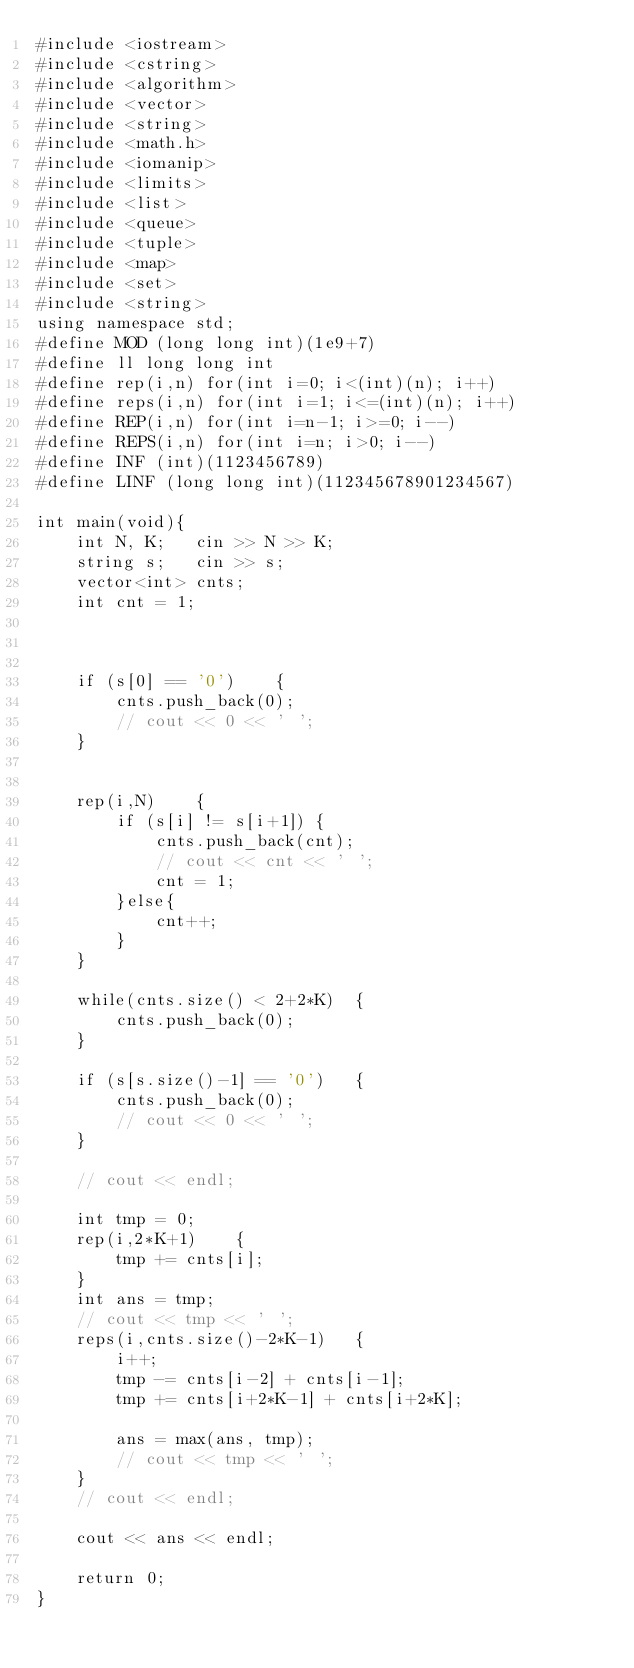<code> <loc_0><loc_0><loc_500><loc_500><_C++_>#include <iostream>
#include <cstring>
#include <algorithm>
#include <vector>
#include <string>
#include <math.h>
#include <iomanip>
#include <limits>
#include <list>
#include <queue>
#include <tuple>
#include <map>
#include <set>
#include <string>
using namespace std;
#define MOD (long long int)(1e9+7)
#define ll long long int
#define rep(i,n) for(int i=0; i<(int)(n); i++)
#define reps(i,n) for(int i=1; i<=(int)(n); i++)
#define REP(i,n) for(int i=n-1; i>=0; i--)
#define REPS(i,n) for(int i=n; i>0; i--)
#define INF (int)(1123456789)
#define LINF (long long int)(112345678901234567)

int main(void){
	int N, K;	cin >> N >> K;
	string s;	cin >> s;
	vector<int> cnts;
	int cnt = 1;



	if (s[0] == '0')	{
		cnts.push_back(0);
		// cout << 0 << ' ';
	}


	rep(i,N)	{
		if (s[i] != s[i+1])	{
			cnts.push_back(cnt);
			// cout << cnt << ' ';
			cnt = 1;
		}else{
			cnt++;
		}
	}

	while(cnts.size() < 2+2*K)	{
		cnts.push_back(0);
	}

	if (s[s.size()-1] == '0')	{
		cnts.push_back(0);
		// cout << 0 << ' ';
	}

	// cout << endl;

	int tmp = 0;
	rep(i,2*K+1)	{
		tmp += cnts[i];
	}
	int ans = tmp;
	// cout << tmp << ' ';
	reps(i,cnts.size()-2*K-1)	{
		i++;
		tmp -= cnts[i-2] + cnts[i-1];
		tmp += cnts[i+2*K-1] + cnts[i+2*K];

		ans = max(ans, tmp);
		// cout << tmp << ' ';
	}
	// cout << endl;

	cout << ans << endl;

	return 0;
}
</code> 